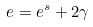Convert formula to latex. <formula><loc_0><loc_0><loc_500><loc_500>e = e ^ { s } + 2 \gamma</formula> 